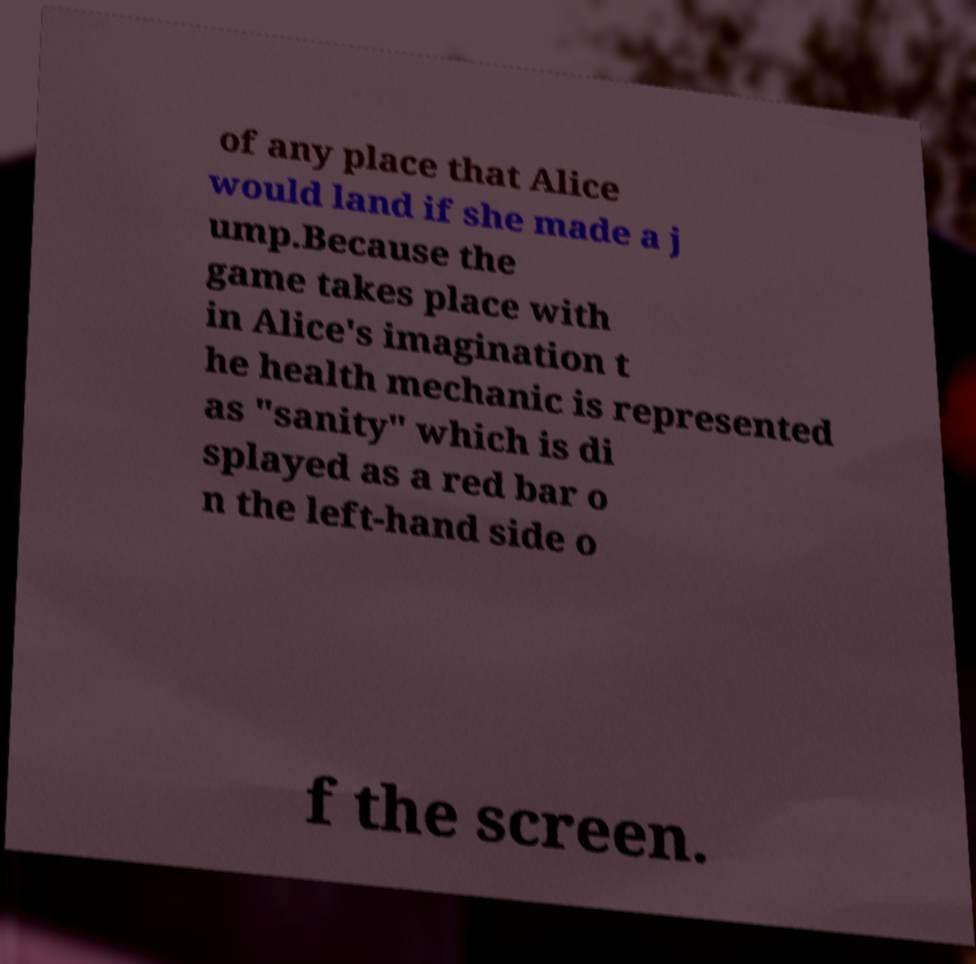Could you extract and type out the text from this image? of any place that Alice would land if she made a j ump.Because the game takes place with in Alice's imagination t he health mechanic is represented as "sanity" which is di splayed as a red bar o n the left-hand side o f the screen. 